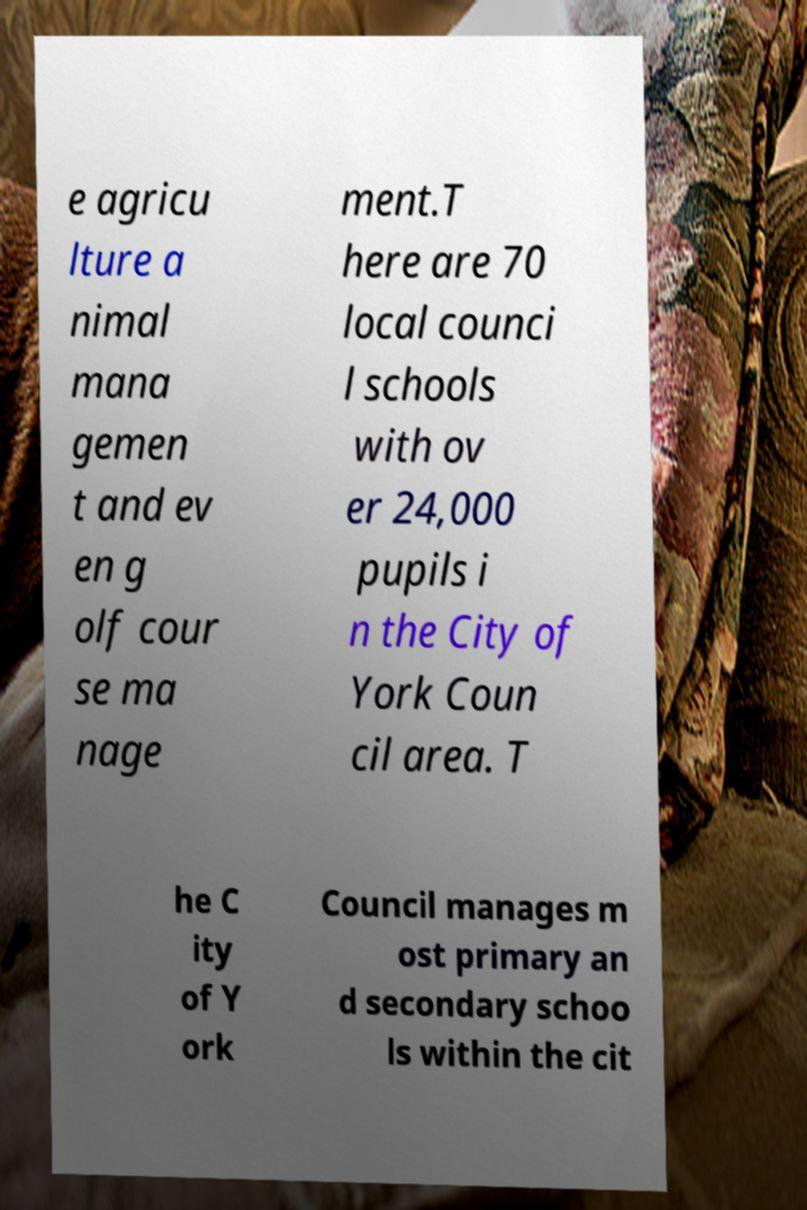Please identify and transcribe the text found in this image. e agricu lture a nimal mana gemen t and ev en g olf cour se ma nage ment.T here are 70 local counci l schools with ov er 24,000 pupils i n the City of York Coun cil area. T he C ity of Y ork Council manages m ost primary an d secondary schoo ls within the cit 